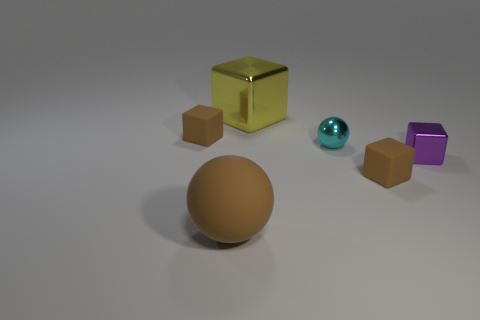Add 3 tiny metallic things. How many objects exist? 9 Subtract all small blocks. How many blocks are left? 1 Subtract all brown spheres. How many spheres are left? 1 Subtract all cyan spheres. Subtract all red cylinders. How many spheres are left? 1 Subtract all green spheres. How many yellow blocks are left? 1 Subtract all big cyan shiny balls. Subtract all yellow metallic things. How many objects are left? 5 Add 5 tiny metal balls. How many tiny metal balls are left? 6 Add 6 big gray metallic balls. How many big gray metallic balls exist? 6 Subtract 1 yellow cubes. How many objects are left? 5 Subtract all balls. How many objects are left? 4 